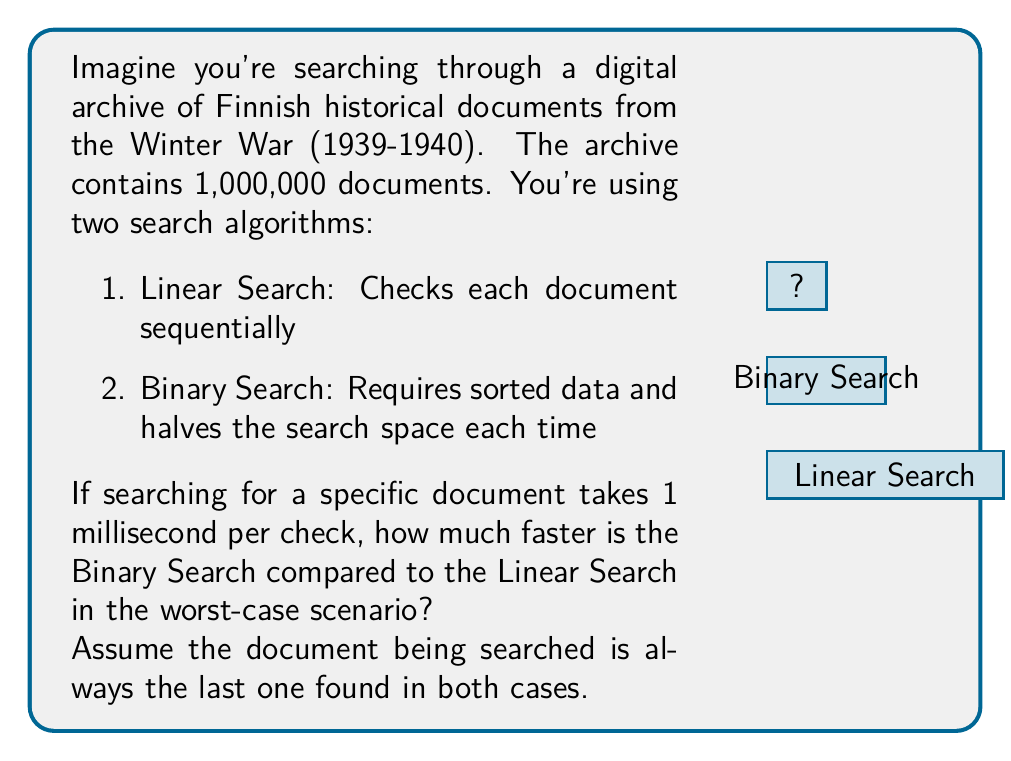Could you help me with this problem? Let's approach this step-by-step:

1) For Linear Search:
   - Worst case: check all 1,000,000 documents
   - Time = $1,000,000 \times 1$ ms $= 1,000,000$ ms

2) For Binary Search:
   - Worst case: $\log_2(1,000,000)$ checks
   - $\log_2(1,000,000) = \log_2(10^6) = 6 \log_2(10) \approx 19.93$
   - We round up to 20 checks since we can't do a fractional check
   - Time = $20 \times 1$ ms $= 20$ ms

3) To find how much faster Binary Search is:
   $$\text{Speed-up factor} = \frac{\text{Linear Search Time}}{\text{Binary Search Time}}$$
   $$= \frac{1,000,000}{20} = 50,000$$

Therefore, in this worst-case scenario, Binary Search is 50,000 times faster than Linear Search.

This demonstrates the efficiency of Binary Search for large datasets, which could be crucial when dealing with extensive historical archives.
Answer: 50,000 times faster 